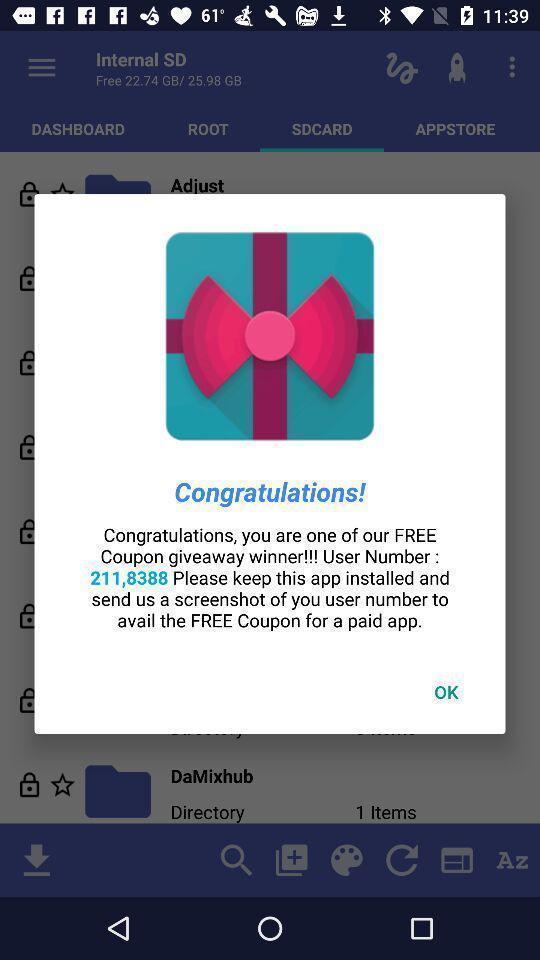Describe the key features of this screenshot. Pop-up displaying the number to avail the free coupon. 